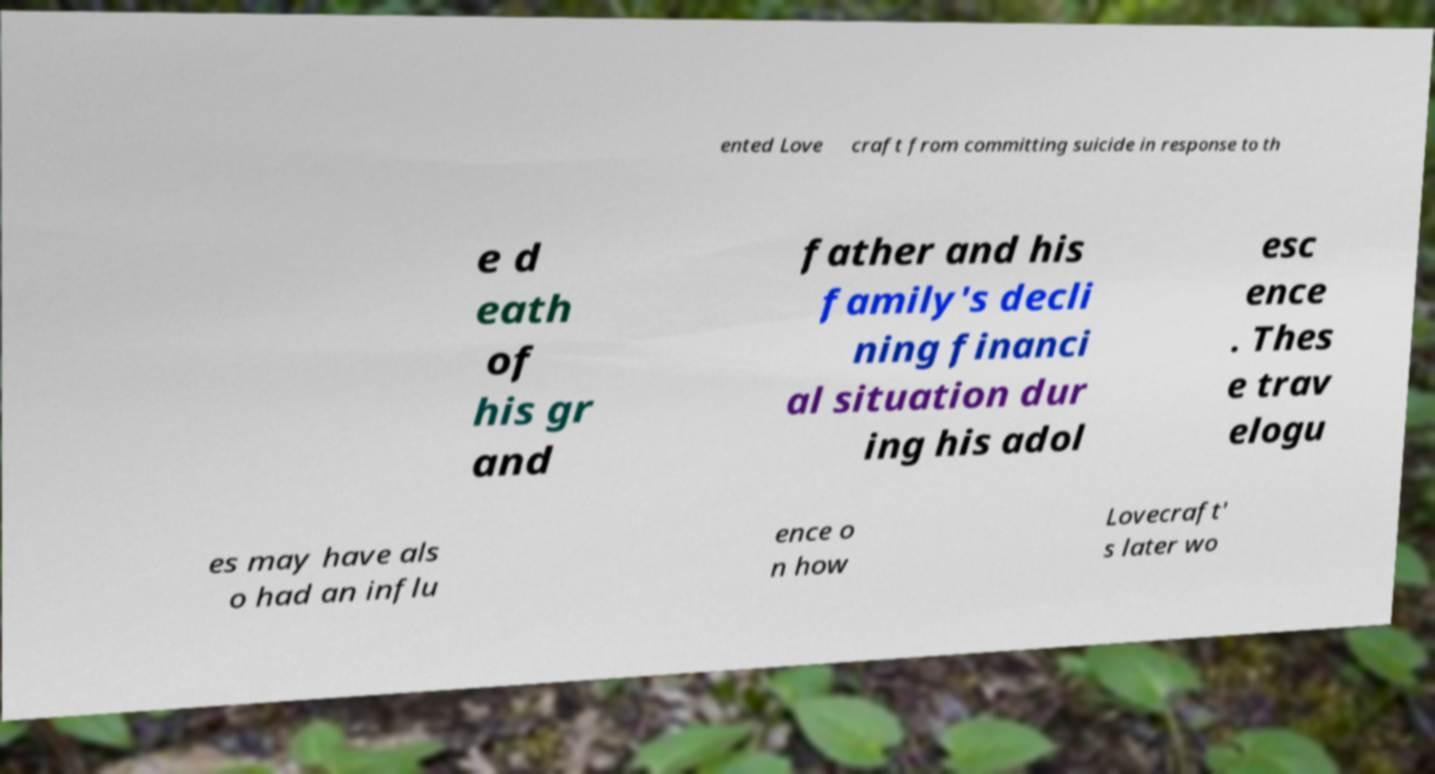There's text embedded in this image that I need extracted. Can you transcribe it verbatim? ented Love craft from committing suicide in response to th e d eath of his gr and father and his family's decli ning financi al situation dur ing his adol esc ence . Thes e trav elogu es may have als o had an influ ence o n how Lovecraft' s later wo 